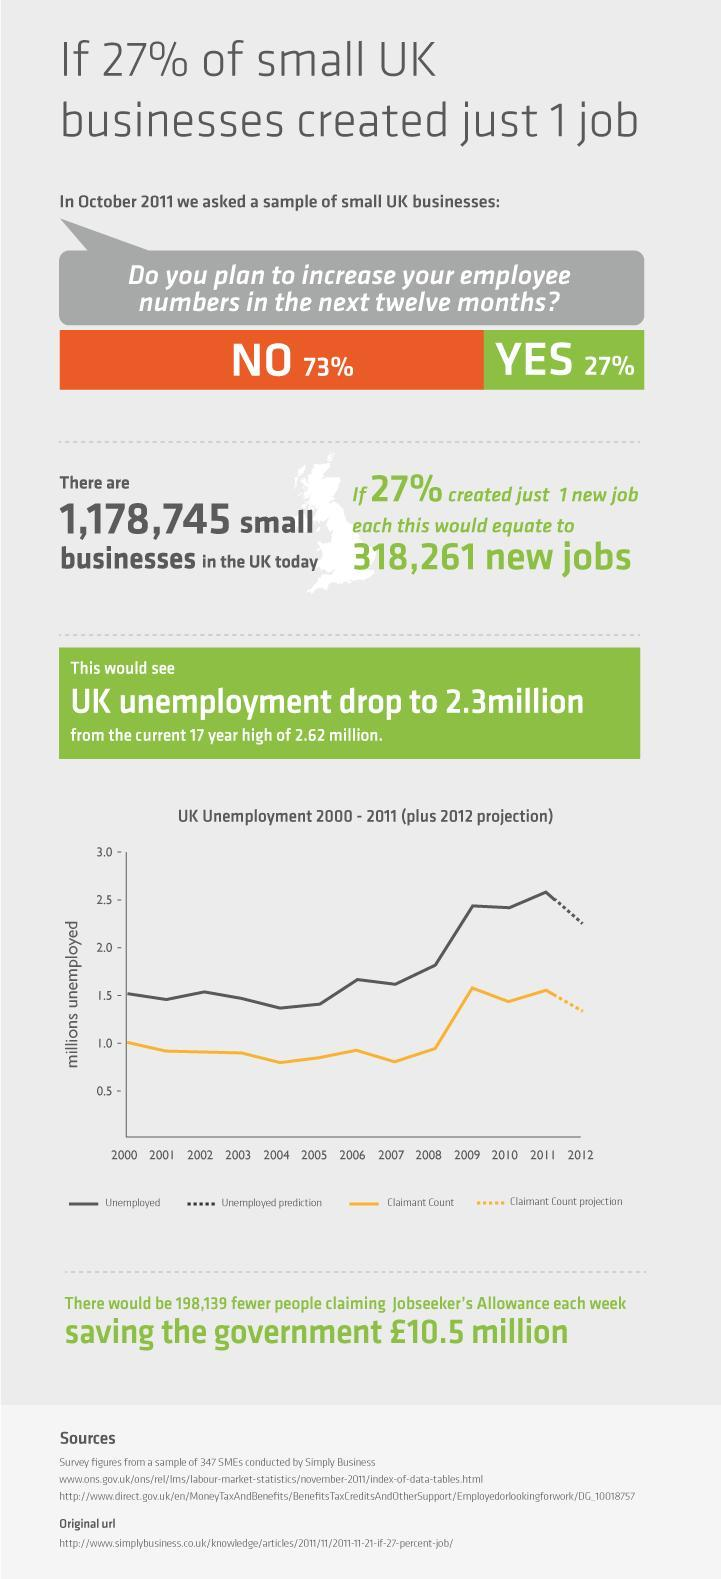How many small businesses are there in UK today ?
Answer the question with a short phrase. 1,178,745 What percentage of employers were willing to increase their employee numbers ? 27% What percentage of employers were unwilling to increase their employee numbers ? 73% What does the continuous yellow line plotted on the graph indicate ? Claimant count How many more jobs will be created if 27% of the small business firms created one job each ? 318,261 What is the colour used to represent unemployed on the graph - black, yellow or green? Black 